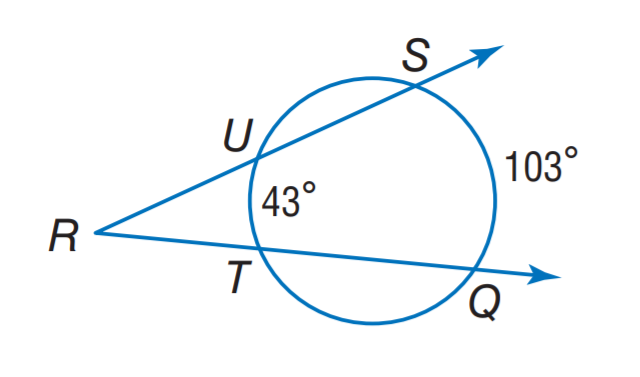Answer the mathemtical geometry problem and directly provide the correct option letter.
Question: Find m \angle R.
Choices: A: 13 B: 30 C: 43 D: 77 B 